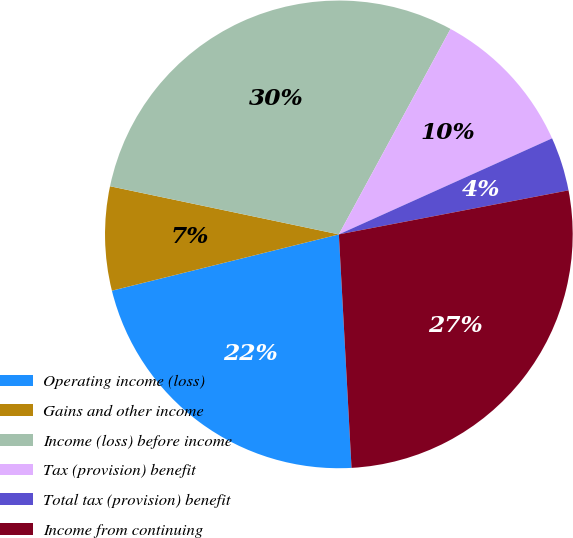Convert chart. <chart><loc_0><loc_0><loc_500><loc_500><pie_chart><fcel>Operating income (loss)<fcel>Gains and other income<fcel>Income (loss) before income<fcel>Tax (provision) benefit<fcel>Total tax (provision) benefit<fcel>Income from continuing<nl><fcel>21.99%<fcel>7.17%<fcel>29.62%<fcel>10.34%<fcel>3.72%<fcel>27.15%<nl></chart> 